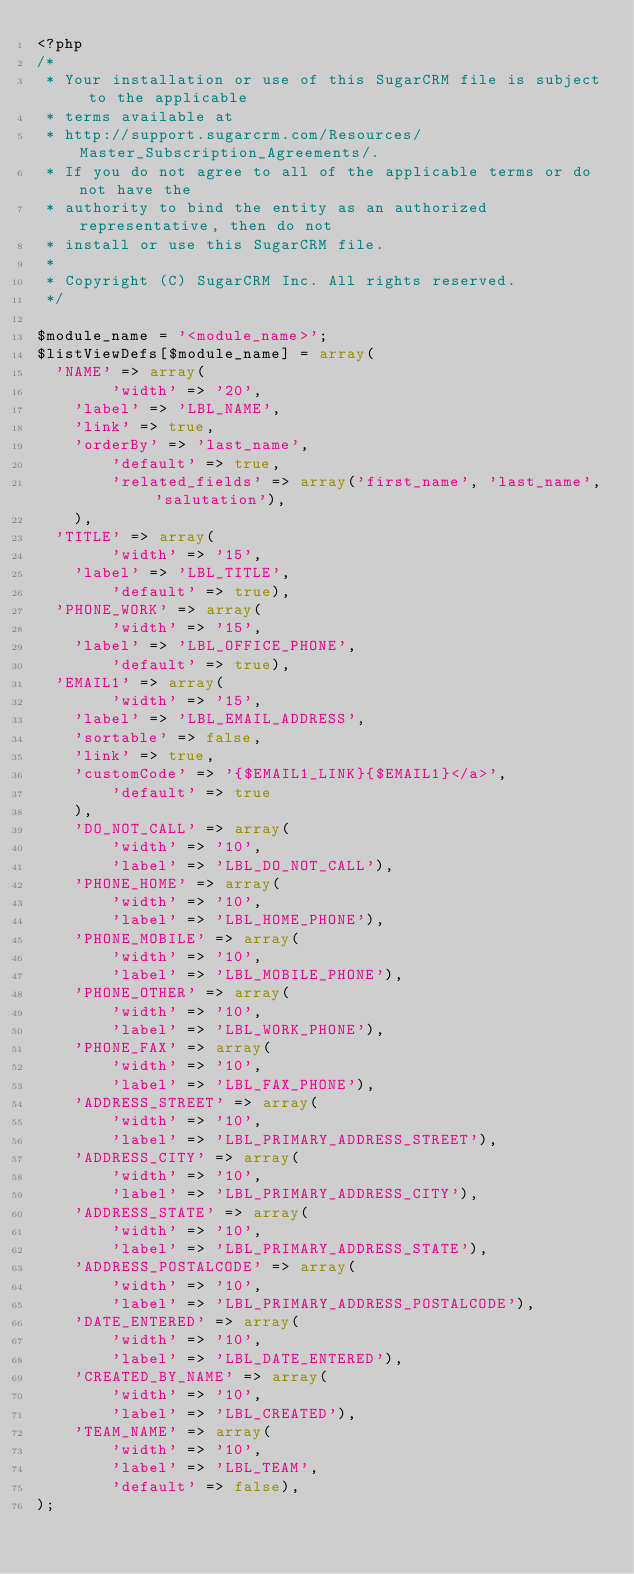Convert code to text. <code><loc_0><loc_0><loc_500><loc_500><_PHP_><?php
/*
 * Your installation or use of this SugarCRM file is subject to the applicable
 * terms available at
 * http://support.sugarcrm.com/Resources/Master_Subscription_Agreements/.
 * If you do not agree to all of the applicable terms or do not have the
 * authority to bind the entity as an authorized representative, then do not
 * install or use this SugarCRM file.
 *
 * Copyright (C) SugarCRM Inc. All rights reserved.
 */

$module_name = '<module_name>';
$listViewDefs[$module_name] = array(
	'NAME' => array(
        'width' => '20',
		'label' => 'LBL_NAME', 
		'link' => true,
		'orderBy' => 'last_name',
        'default' => true,
        'related_fields' => array('first_name', 'last_name', 'salutation'),
		), 
	'TITLE' => array(
        'width' => '15',
		'label' => 'LBL_TITLE',
        'default' => true), 
	'PHONE_WORK' => array(
        'width' => '15',
		'label' => 'LBL_OFFICE_PHONE',
        'default' => true),
	'EMAIL1' => array(
        'width' => '15',
		'label' => 'LBL_EMAIL_ADDRESS',
		'sortable' => false,
		'link' => true,
		'customCode' => '{$EMAIL1_LINK}{$EMAIL1}</a>',
        'default' => true
		),  
    'DO_NOT_CALL' => array(
        'width' => '10', 
        'label' => 'LBL_DO_NOT_CALL'),
    'PHONE_HOME' => array(
        'width' => '10', 
        'label' => 'LBL_HOME_PHONE'),
    'PHONE_MOBILE' => array(
        'width' => '10', 
        'label' => 'LBL_MOBILE_PHONE'),
    'PHONE_OTHER' => array(
        'width' => '10', 
        'label' => 'LBL_WORK_PHONE'),
    'PHONE_FAX' => array(
        'width' => '10', 
        'label' => 'LBL_FAX_PHONE'),
    'ADDRESS_STREET' => array(
        'width' => '10', 
        'label' => 'LBL_PRIMARY_ADDRESS_STREET'),
    'ADDRESS_CITY' => array(
        'width' => '10', 
        'label' => 'LBL_PRIMARY_ADDRESS_CITY'),
    'ADDRESS_STATE' => array(
        'width' => '10', 
        'label' => 'LBL_PRIMARY_ADDRESS_STATE'),
    'ADDRESS_POSTALCODE' => array(
        'width' => '10', 
        'label' => 'LBL_PRIMARY_ADDRESS_POSTALCODE'),
    'DATE_ENTERED' => array(
        'width' => '10', 
        'label' => 'LBL_DATE_ENTERED'),
    'CREATED_BY_NAME' => array(
        'width' => '10', 
        'label' => 'LBL_CREATED'),
    'TEAM_NAME' => array(
        'width' => '10', 
        'label' => 'LBL_TEAM',
        'default' => false),
);
</code> 